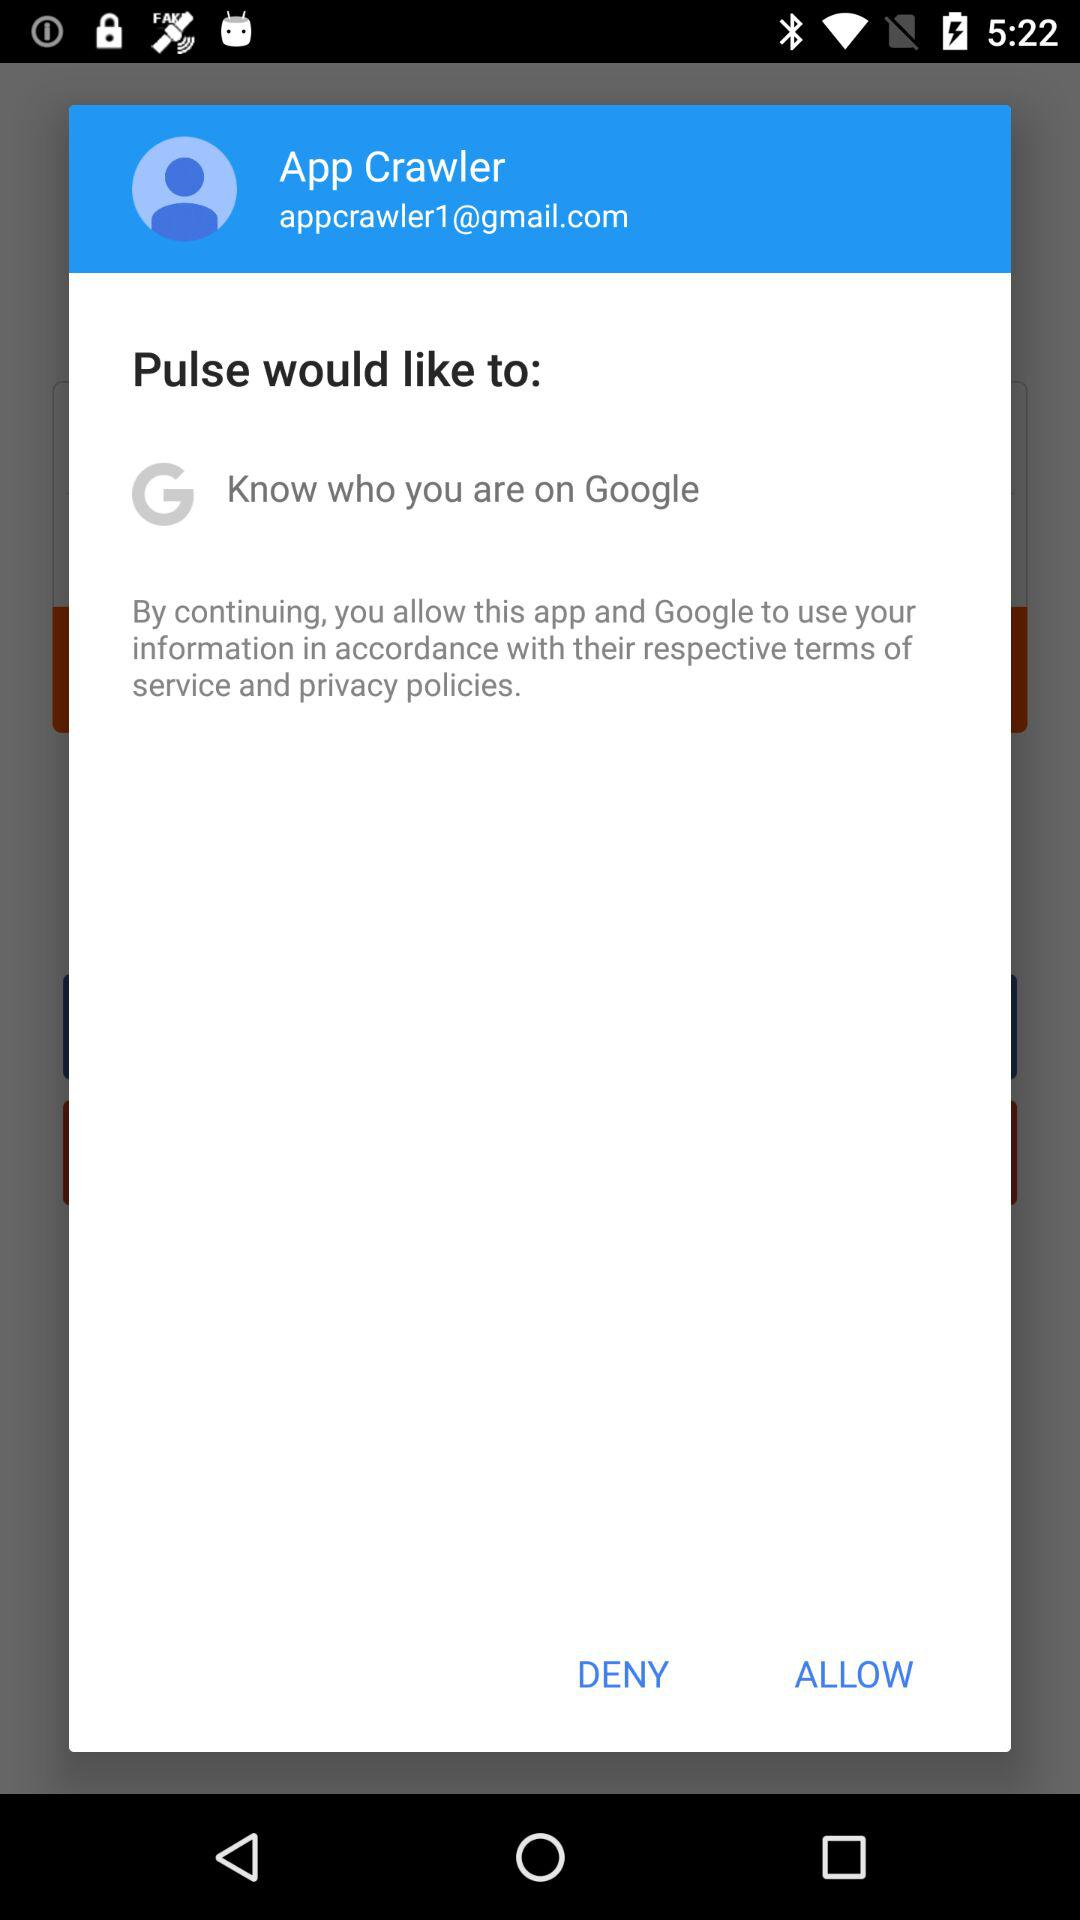What is the mentioned email ID? The mentioned email ID is appcrawler1@gmail.com. 